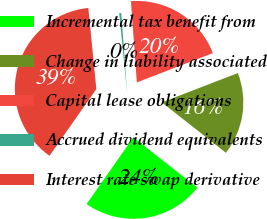Convert chart. <chart><loc_0><loc_0><loc_500><loc_500><pie_chart><fcel>Incremental tax benefit from<fcel>Change in liability associated<fcel>Capital lease obligations<fcel>Accrued dividend equivalents<fcel>Interest rate swap derivative<nl><fcel>24.13%<fcel>16.47%<fcel>20.3%<fcel>0.4%<fcel>38.7%<nl></chart> 